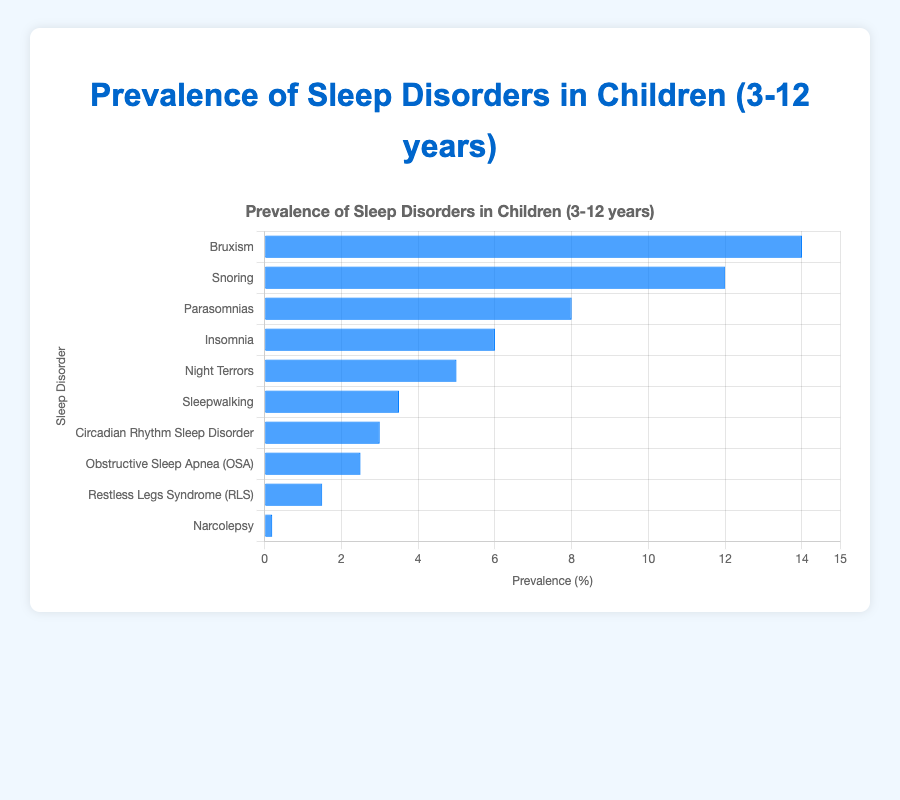What sleep disorder has the highest prevalence in children aged 3-12 years? The tallest bar in the bar chart represents the sleep disorder with the highest prevalence. By observing the bar heights, we see that "Bruxism" has the highest prevalence.
Answer: Bruxism Which sleep disorder has a prevalence of 6%? Identify the bar that corresponds to the prevalence value of 6% by checking the bar lengths. The label "Insomnia" aligns with the bar indicating 6%.
Answer: Insomnia What is the combined prevalence of Obstructive Sleep Apnea (OSA) and Restless Legs Syndrome (RLS)? The prevalence of Obstructive Sleep Apnea (OSA) is 2.5% and Restless Legs Syndrome (RLS) is 1.5%. Adding these percentages together: 2.5% + 1.5% = 4.0%.
Answer: 4.0% Compare the prevalence of Snoring and Night Terrors. Which one is more common? Look at the lengths of the bars representing "Snoring" and "Night Terrors". The bar for "Snoring" is higher at 12%, while "Night Terrors" is at 5%. Hence, Snoring is more common.
Answer: Snoring How much more common is Bruxism compared to Narcolepsy? Find the prevalence percentages of Bruxism and Narcolepsy, which are 14% and 0.2% respectively. Calculate the difference: 14% - 0.2% = 13.8%.
Answer: 13.8% What is the average prevalence percentage of Parasomnias, Night Terrors, and Sleepwalking? Add the prevalence percentages of Parasomnias (8%), Night Terrors (5%), and Sleepwalking (3.5%) and then divide by 3: (8% + 5% + 3.5%) / 3 = 5.5%.
Answer: 5.5% Rank all sleep disorders from the most prevalent to the least prevalent. Arrange the sleep disorders based on the heights of their respective bars from highest to lowest. The ranking is: Bruxism (14%), Snoring (12%), Parasomnias (8%), Insomnia (6%), Night Terrors (5%), Sleepwalking (3.5%), Circadian Rhythm Sleep Disorder (3%), Obstructive Sleep Apnea (OSA) (2.5%), Restless Legs Syndrome (RLS) (1.5%), Narcolepsy (0.2%).
Answer: Bruxism, Snoring, Parasomnias, Insomnia, Night Terrors, Sleepwalking, Circadian Rhythm Sleep Disorder, Obstructive Sleep Apnea (OSA), Restless Legs Syndrome (RLS), Narcolepsy Identify the disorders with a prevalence of 3% or higher but less than 5%. Check bars whose length fall between 3% and 5%. The corresponding labels are "Night Terrors" (5%), "Sleepwalking" (3.5%), and "Circadian Rhythm Sleep Disorder" (3%). The ones meeting the criteria are "Sleepwalking" and "Circadian Rhythm Sleep Disorder".
Answer: Sleepwalking, Circadian Rhythm Sleep Disorder 